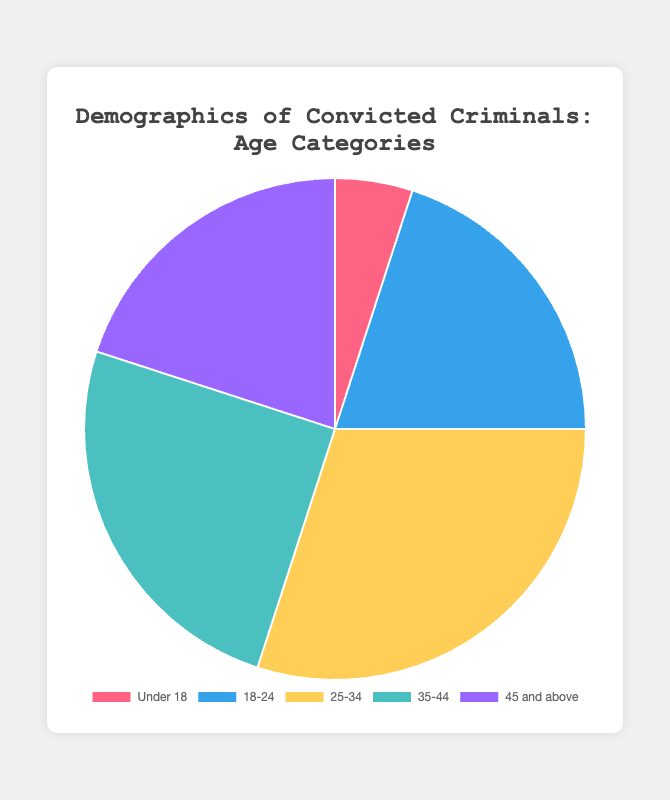Which age category has the highest percentage of convicted criminals? The figure shows five age categories with their respective percentages of convicted criminals. By observing the size of each section in the pie chart, the category "25-34" appears the largest, indicating this age group has the highest percentage.
Answer: 25-34 How many age categories have a percentage of convicted criminals equal to or greater than 20%? By examining the pie chart, we can see the sections labeled "18-24", "25-34", "35-44", and "45 and above" all have sizeable proportions. Counting these sections, we determine that there are four age categories with percentages equal to or greater than 20%.
Answer: 4 What is the total percentage of convicted criminals in the "Under 18" and "45 and above" age categories combined? By looking at the figures, the "Under 18" category accounts for 5% and the "45 and above" category accounts for 20%. Adding these percentages together, 5 + 20, we get a total of 25%.
Answer: 25% Which two age categories have the same percentage of convicted criminals? Among the five categories, observing the pie chart reveals that both the "18-24" and "45 and above" sections share the same size, each constituting 20% of the total convicted criminals.
Answer: 18-24 and 45 and above What is the difference in percentage between the "25-34" and "Under 18" age categories? The pie chart shows that the "25-34" category has 30% of convicted criminals, while the "Under 18" category has 5%. Subtracting 5% from 30%, we get a difference of 25%.
Answer: 25% What is the average percentage of the "18-24", "25-34", and "35-44" age categories? Adding the percentages of "18-24" (20%), "25-34" (30%), and "35-44" (25%), we get a total of 75%. Dividing this sum by the number of categories (3) gives us the average: 75% / 3 = 25%.
Answer: 25% Which age category marked in blue has what percentage for convicted criminals? By analyzing the colors in the pie chart, we find that the category marked in blue corresponds to "18-24." Observing the chart further, we see that this category has a percentage of 20%.
Answer: 18-24, 20% What is the combined percentage of convicted criminals for age categories below 35 years old? Adding the percentages for "Under 18" (5%), "18-24" (20%), and "25-34" (30%): 5 + 20 + 30 = 55%. This sum gives the combined percentage of convicted criminals for these age categories.
Answer: 55% Which age category marked in yellow has what percentage for convicted criminals? By examining the colors on the pie chart, we determine that the category marked in yellow is "25-34," which constitutes 30% of the convicted criminals as shown in the chart.
Answer: 25-34, 30% 